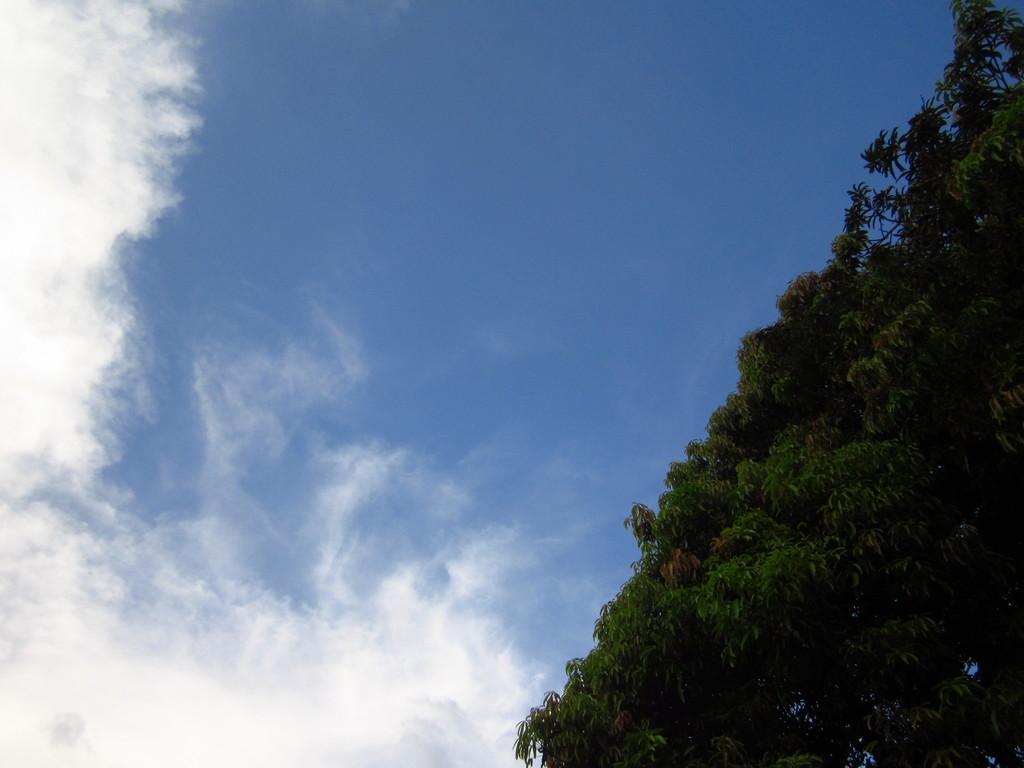In one or two sentences, can you explain what this image depicts? In this picture we can see trees and in the background we can see sky with clouds. 